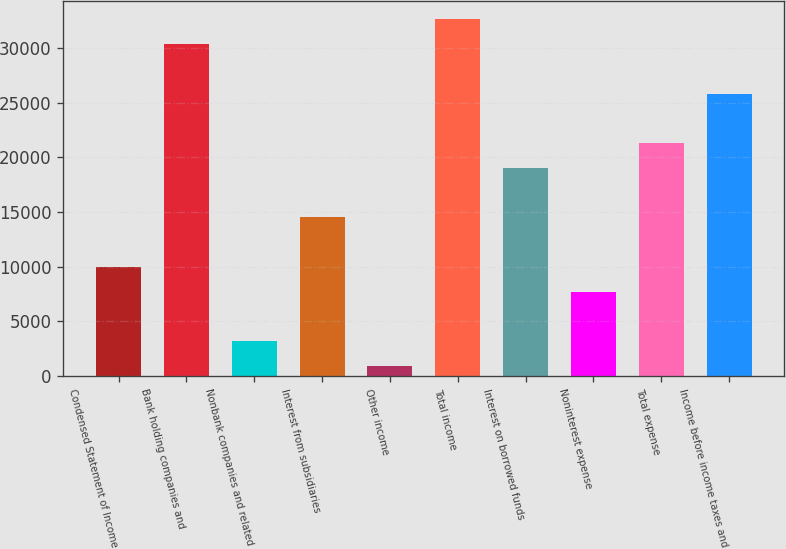<chart> <loc_0><loc_0><loc_500><loc_500><bar_chart><fcel>Condensed Statement of Income<fcel>Bank holding companies and<fcel>Nonbank companies and related<fcel>Interest from subsidiaries<fcel>Other income<fcel>Total income<fcel>Interest on borrowed funds<fcel>Noninterest expense<fcel>Total expense<fcel>Income before income taxes and<nl><fcel>9994.8<fcel>30368.1<fcel>3203.7<fcel>14522.2<fcel>940<fcel>32631.8<fcel>19049.6<fcel>7731.1<fcel>21313.3<fcel>25840.7<nl></chart> 